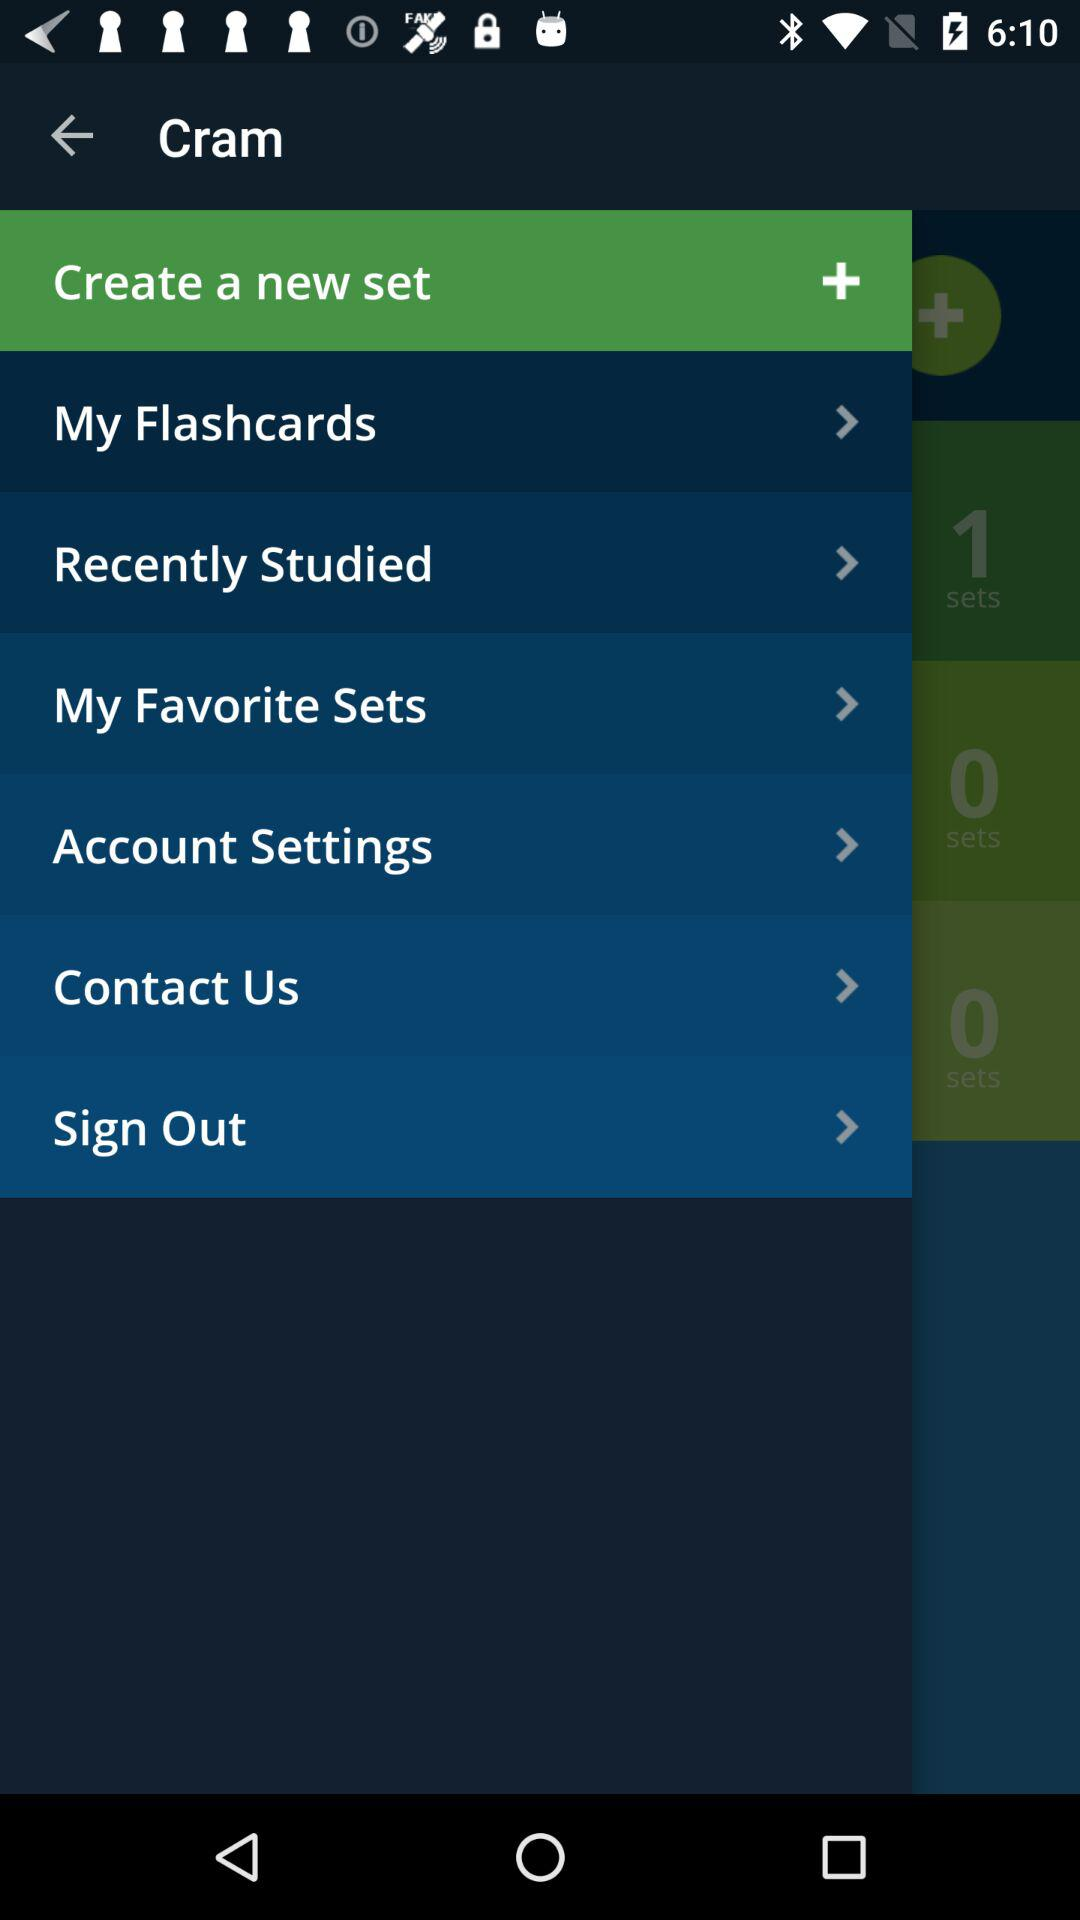Which methods of contact are available?
When the provided information is insufficient, respond with <no answer>. <no answer> 